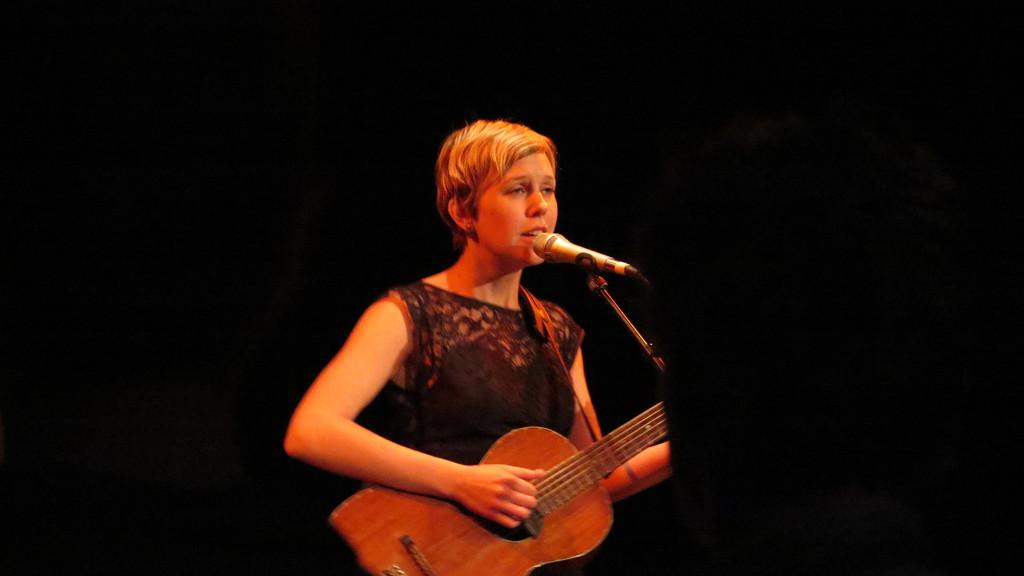Who is the main subject in the image? There is a lady in the image. What is the lady wearing? The lady is wearing a black dress. What is the lady doing in the image? The lady is playing a guitar and singing. What object is in front of the lady? There is a microphone in front of the lady. Is there a team of cooks preparing a meal in the image? No, there is no team of cooks or any indication of meal preparation in the image. 